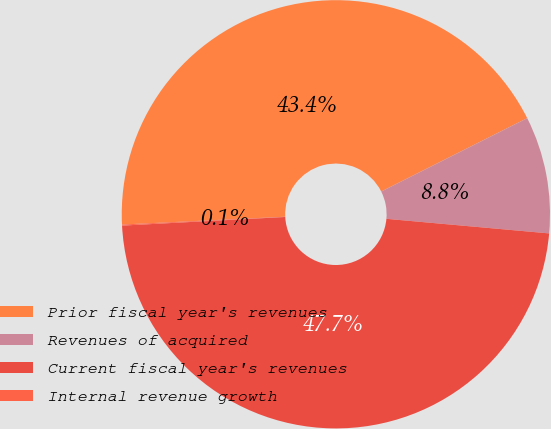Convert chart to OTSL. <chart><loc_0><loc_0><loc_500><loc_500><pie_chart><fcel>Prior fiscal year's revenues<fcel>Revenues of acquired<fcel>Current fiscal year's revenues<fcel>Internal revenue growth<nl><fcel>43.35%<fcel>8.83%<fcel>47.73%<fcel>0.08%<nl></chart> 